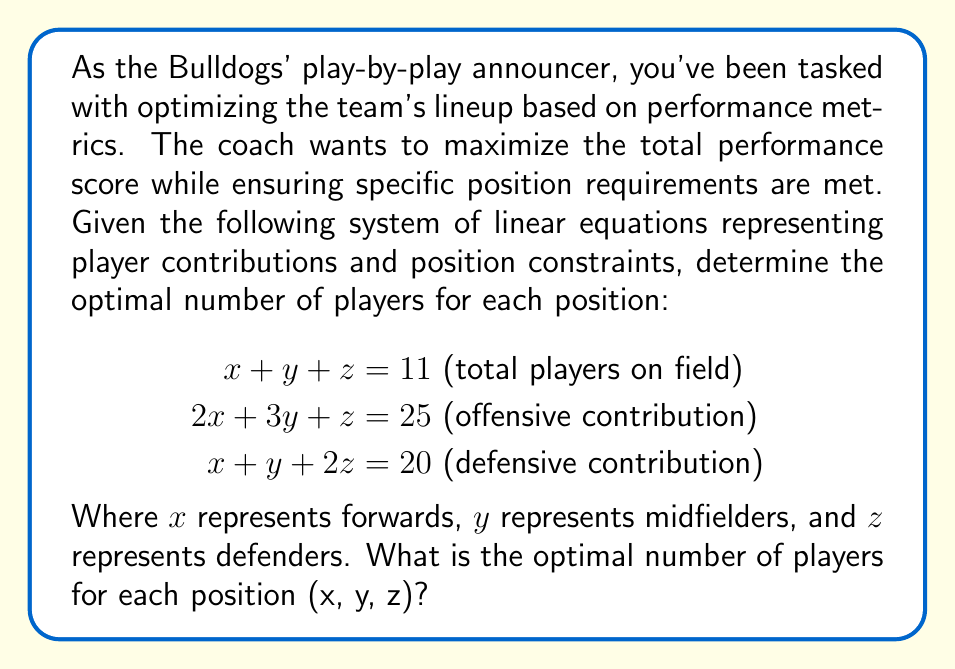Show me your answer to this math problem. To solve this system of linear equations, we'll use the elimination method:

1) First, let's eliminate x by subtracting equation (1) from equation (2):
   $$(2x + 3y + z) - (x + y + z) = 25 - 11$$
   $$x + 2y = 14 \text{ (equation 4)}$$

2) Now, let's eliminate x by subtracting equation (1) from equation (3):
   $$(x + y + 2z) - (x + y + z) = 20 - 11$$
   $$z = 9 \text{ (equation 5)}$$

3) Substitute z = 9 into equation (1):
   $$x + y + 9 = 11$$
   $$x + y = 2 \text{ (equation 6)}$$

4) Now we have two equations with two unknowns (x and y):
   $$x + 2y = 14 \text{ (equation 4)}$$
   $$x + y = 2 \text{ (equation 6)}$$

5) Subtract equation (6) from equation (4):
   $$y = 12$$

6) Substitute y = 12 into equation (6):
   $$x + 12 = 2$$
   $$x = -10$$

7) Therefore, the solution is:
   $$x = -10, y = 12, z = 9$$

However, since we can't have a negative number of players, this solution is not feasible in the real world. The closest feasible solution would be:

$$x = 0 \text{ (forwards)}$$
$$y = 2 \text{ (midfielders)}$$
$$z = 9 \text{ (defenders)}$$

This solution satisfies the total player constraint (0 + 2 + 9 = 11) and is the closest to optimizing the performance metrics while maintaining non-negative values.
Answer: (0, 2, 9) 